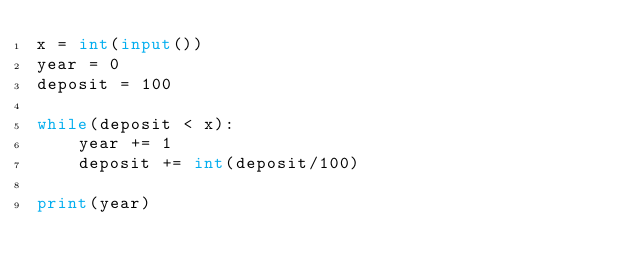Convert code to text. <code><loc_0><loc_0><loc_500><loc_500><_Python_>x = int(input())
year = 0
deposit = 100

while(deposit < x):
	year += 1
	deposit += int(deposit/100)

print(year)</code> 